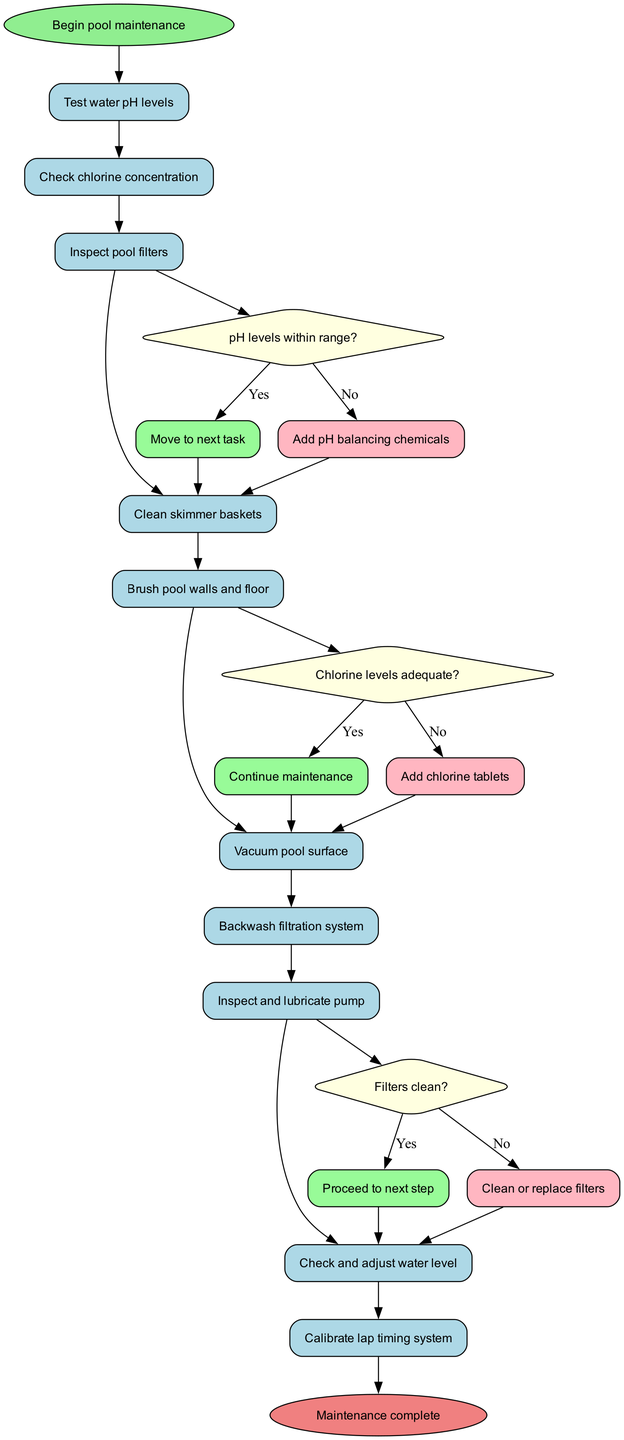What is the starting node of this maintenance procedure? The starting node is explicitly labeled as "Begin pool maintenance" in the diagram. Therefore, the answer is the name of this node.
Answer: Begin pool maintenance How many activities are listed in the diagram? The diagram includes a total of 10 activities, which are outlined in the activities section of the data.
Answer: 10 What actions are taken if the pH levels are not within range? If the pH levels are not within range, the flow directs to the action of adding pH balancing chemicals, as indicated by the 'no' edge from the decision node.
Answer: Add pH balancing chemicals What happens if chlorine levels are adequate? When the chlorine levels are adequate, the flow continues to the next maintenance step without any interruptions. This is represented by the 'yes' edge leading to the next task.
Answer: Continue maintenance Which activity follows the inspection of pool filters? Following the inspection of pool filters, the next activity stated in the diagram is to clean skimmer baskets, indicated by the sequential flow from one activity to the next.
Answer: Clean skimmer baskets What condition must be met to proceed after inspecting the pump? The decision after inspecting the pump checks if the filters are clean; if they are, the flow proceeds to the next activity, showing a conditional requirement for continuation.
Answer: Filters clean? Why is backwashing the filtration system included after vacuuming the pool surface? Backwashing the filtration system is included after vacuuming to ensure the pool's filtration system is functioning effectively after debris has been removed. This strategic ordering helps maintain water quality.
Answer: To maintain water quality How many decision points are there in this maintenance procedure? There are three distinct decision points in the diagram, represented by the three conditional diamonds that determine the next steps based on specific conditions.
Answer: 3 What is the final node of the maintenance process? The end of the maintenance process is labeled as "Maintenance complete," indicating the conclusion of the entire procedure. This conclusion is marked clearly in the diagram.
Answer: Maintenance complete 